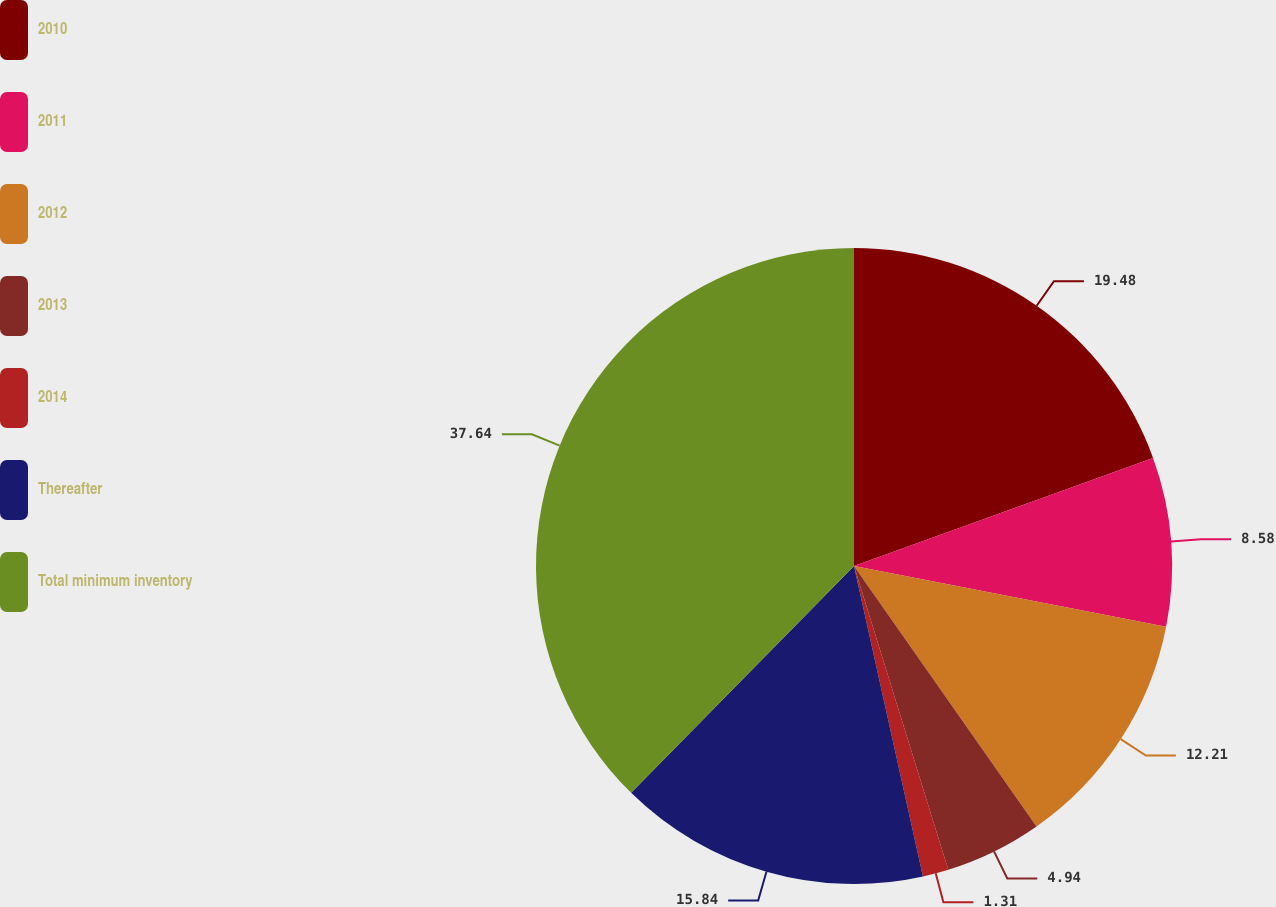<chart> <loc_0><loc_0><loc_500><loc_500><pie_chart><fcel>2010<fcel>2011<fcel>2012<fcel>2013<fcel>2014<fcel>Thereafter<fcel>Total minimum inventory<nl><fcel>19.48%<fcel>8.58%<fcel>12.21%<fcel>4.94%<fcel>1.31%<fcel>15.84%<fcel>37.64%<nl></chart> 